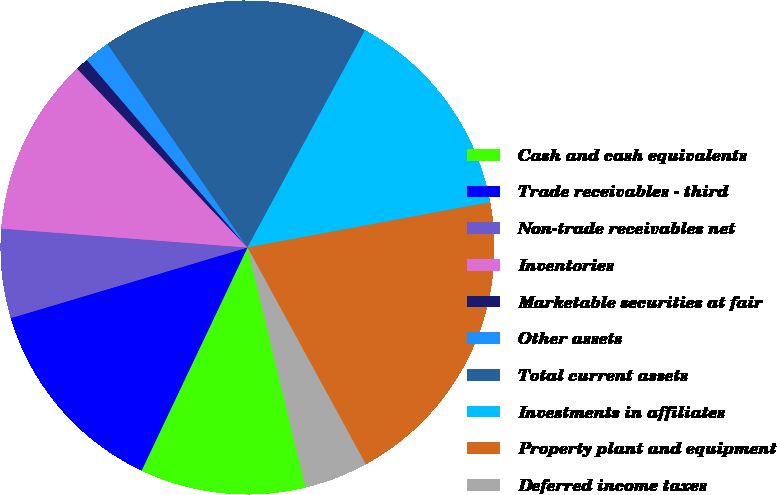Convert chart to OTSL. <chart><loc_0><loc_0><loc_500><loc_500><pie_chart><fcel>Cash and cash equivalents<fcel>Trade receivables - third<fcel>Non-trade receivables net<fcel>Inventories<fcel>Marketable securities at fair<fcel>Other assets<fcel>Total current assets<fcel>Investments in affiliates<fcel>Property plant and equipment<fcel>Deferred income taxes<nl><fcel>10.83%<fcel>13.33%<fcel>5.84%<fcel>11.66%<fcel>0.84%<fcel>1.68%<fcel>17.49%<fcel>14.16%<fcel>19.99%<fcel>4.17%<nl></chart> 